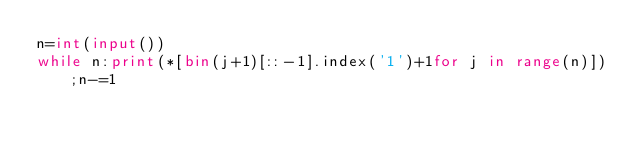Convert code to text. <code><loc_0><loc_0><loc_500><loc_500><_Python_>n=int(input())
while n:print(*[bin(j+1)[::-1].index('1')+1for j in range(n)]);n-=1</code> 